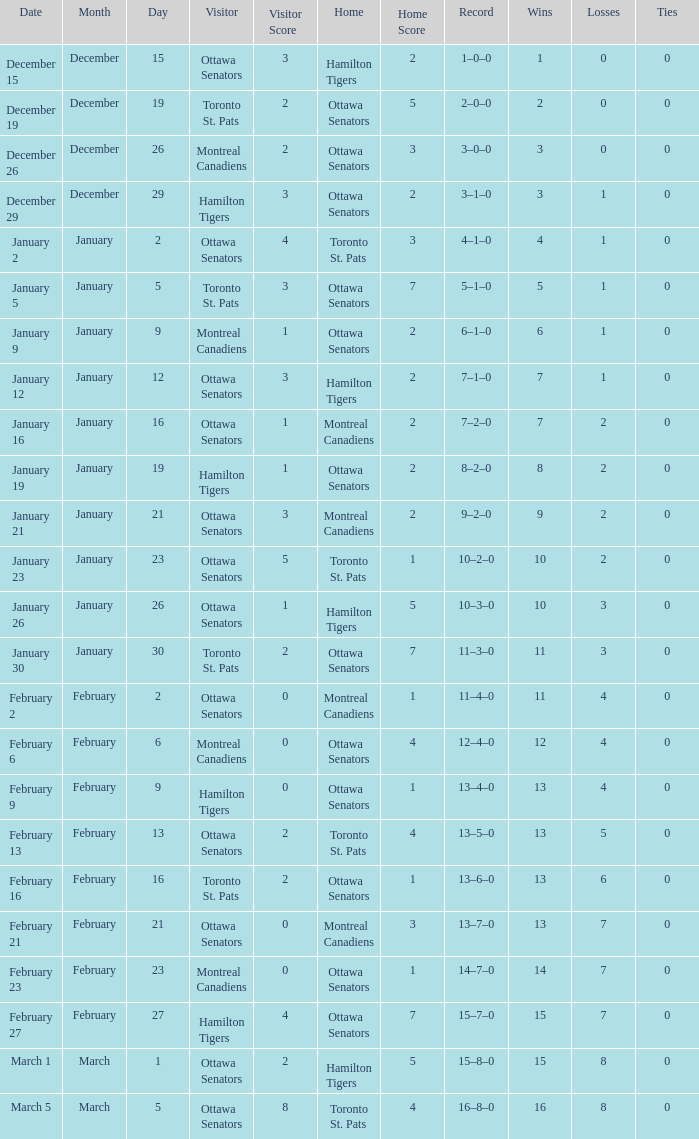What was the outcome on january 12? 3–2. Could you parse the entire table? {'header': ['Date', 'Month', 'Day', 'Visitor', 'Visitor Score', 'Home', 'Home Score', 'Record', 'Wins', 'Losses', 'Ties'], 'rows': [['December 15', 'December', '15', 'Ottawa Senators', '3', 'Hamilton Tigers', '2', '1–0–0', '1', '0', '0'], ['December 19', 'December', '19', 'Toronto St. Pats', '2', 'Ottawa Senators', '5', '2–0–0', '2', '0', '0'], ['December 26', 'December', '26', 'Montreal Canadiens', '2', 'Ottawa Senators', '3', '3–0–0', '3', '0', '0'], ['December 29', 'December', '29', 'Hamilton Tigers', '3', 'Ottawa Senators', '2', '3–1–0', '3', '1', '0'], ['January 2', 'January', '2', 'Ottawa Senators', '4', 'Toronto St. Pats', '3', '4–1–0', '4', '1', '0'], ['January 5', 'January', '5', 'Toronto St. Pats', '3', 'Ottawa Senators', '7', '5–1–0', '5', '1', '0'], ['January 9', 'January', '9', 'Montreal Canadiens', '1', 'Ottawa Senators', '2', '6–1–0', '6', '1', '0'], ['January 12', 'January', '12', 'Ottawa Senators', '3', 'Hamilton Tigers', '2', '7–1–0', '7', '1', '0'], ['January 16', 'January', '16', 'Ottawa Senators', '1', 'Montreal Canadiens', '2', '7–2–0', '7', '2', '0'], ['January 19', 'January', '19', 'Hamilton Tigers', '1', 'Ottawa Senators', '2', '8–2–0', '8', '2', '0'], ['January 21', 'January', '21', 'Ottawa Senators', '3', 'Montreal Canadiens', '2', '9–2–0', '9', '2', '0'], ['January 23', 'January', '23', 'Ottawa Senators', '5', 'Toronto St. Pats', '1', '10–2–0', '10', '2', '0'], ['January 26', 'January', '26', 'Ottawa Senators', '1', 'Hamilton Tigers', '5', '10–3–0', '10', '3', '0'], ['January 30', 'January', '30', 'Toronto St. Pats', '2', 'Ottawa Senators', '7', '11–3–0', '11', '3', '0'], ['February 2', 'February', '2', 'Ottawa Senators', '0', 'Montreal Canadiens', '1', '11–4–0', '11', '4', '0'], ['February 6', 'February', '6', 'Montreal Canadiens', '0', 'Ottawa Senators', '4', '12–4–0', '12', '4', '0'], ['February 9', 'February', '9', 'Hamilton Tigers', '0', 'Ottawa Senators', '1', '13–4–0', '13', '4', '0'], ['February 13', 'February', '13', 'Ottawa Senators', '2', 'Toronto St. Pats', '4', '13–5–0', '13', '5', '0'], ['February 16', 'February', '16', 'Toronto St. Pats', '2', 'Ottawa Senators', '1', '13–6–0', '13', '6', '0'], ['February 21', 'February', '21', 'Ottawa Senators', '0', 'Montreal Canadiens', '3', '13–7–0', '13', '7', '0'], ['February 23', 'February', '23', 'Montreal Canadiens', '0', 'Ottawa Senators', '1', '14–7–0', '14', '7', '0'], ['February 27', 'February', '27', 'Hamilton Tigers', '4', 'Ottawa Senators', '7', '15–7–0', '15', '7', '0'], ['March 1', 'March', '1', 'Ottawa Senators', '2', 'Hamilton Tigers', '5', '15–8–0', '15', '8', '0'], ['March 5', 'March', '5', 'Ottawa Senators', '8', 'Toronto St. Pats', '4', '16–8–0', '16', '8', '0']]} 